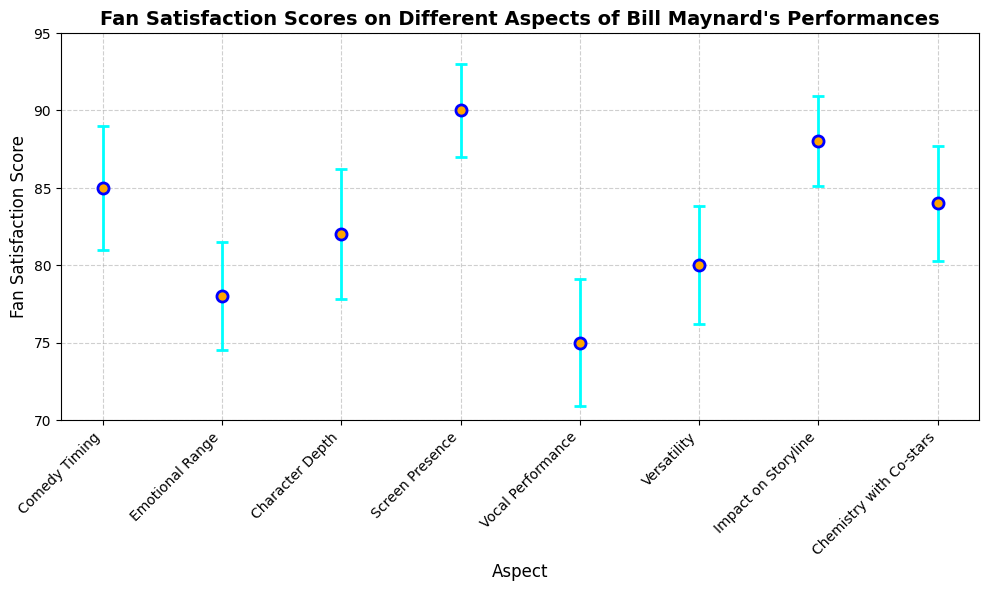What aspect had the highest fan satisfaction score? Examine the heights of the plotted points: the highest point corresponds to Screen Presence with a score of 90.
Answer: Screen Presence Which aspect has the lowest fan satisfaction score? Compare the heights of the plotted points: the lowest point is Vocal Performance with a score of 75.
Answer: Vocal Performance What is the difference in fan satisfaction scores between Comedy Timing and Emotional Range? Comedy Timing has a score of 85, and Emotional Range has a score of 78. Subtract 78 from 85: 85 - 78 = 7.
Answer: 7 How many aspects scored above 80? Count the points above the score of 80: Comedy Timing, Character Depth, Screen Presence, Impact on Storyline, and Chemistry with Co-stars.
Answer: 5 Which two aspects have the closest fan satisfaction scores? Compare the scores of all aspects to find the smallest difference: Emotional Range (78) and Vocal Performance (75) have a difference of 3.
Answer: Emotional Range and Vocal Performance What is the average fan satisfaction score across all aspects? Sum all scores and divide by the number of aspects: (85 + 78 + 82 + 90 + 75 + 80 + 88 + 84) / 8 = 82
Answer: 82 What is the range of fan satisfaction scores? Identify the highest and lowest scores: 90 (Screen Presence) and 75 (Vocal Performance). Subtract the lowest from the highest: 90 - 75 = 15.
Answer: 15 Which aspect has the largest error bar? Examine the lengths of the error bars: Character Depth has the longest error bar with a standard error of 4.2.
Answer: Character Depth What is the relative difference in scores between Impact on Storyline and Versatility? Impact on Storyline has a score of 88, and Versatility has a score of 80. Calculate the difference and then divide by Versatility's score: (88 - 80) / 80 = 0.1 or 10%.
Answer: 10% Between Comedy Timing and Chemistry with Co-stars, which has a lower standard error? Compare the standard errors: Comedy Timing has a standard error of 4, while Chemistry with Co-stars has 3.7.
Answer: Chemistry with Co-stars 